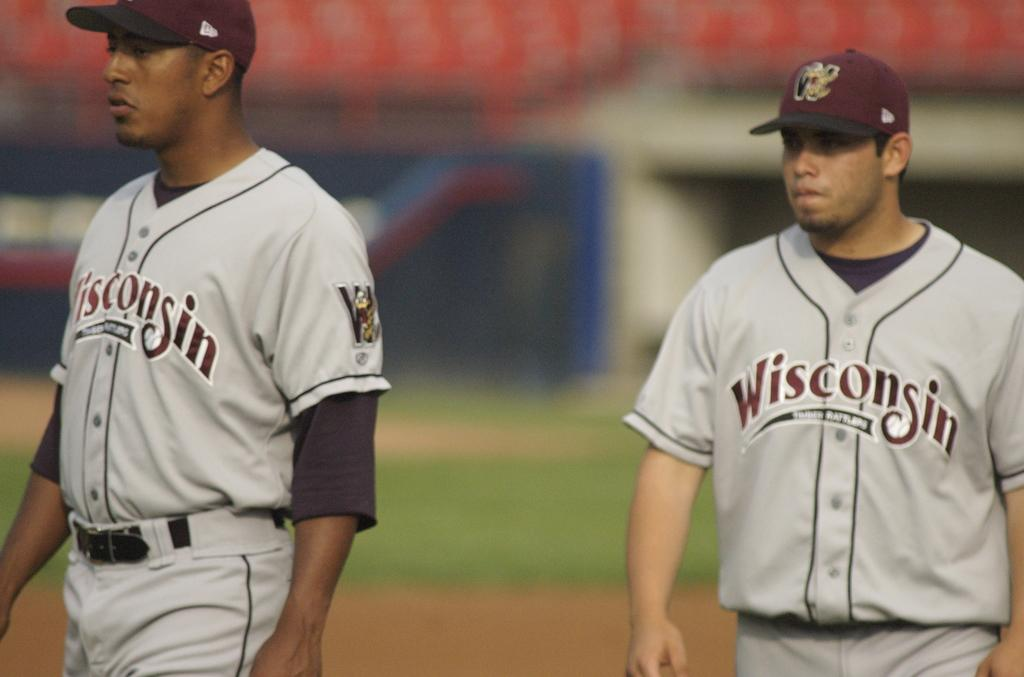Provide a one-sentence caption for the provided image. Two baseball players from the Wisconsin team wearing gray and maroon uniforms stand closely. 